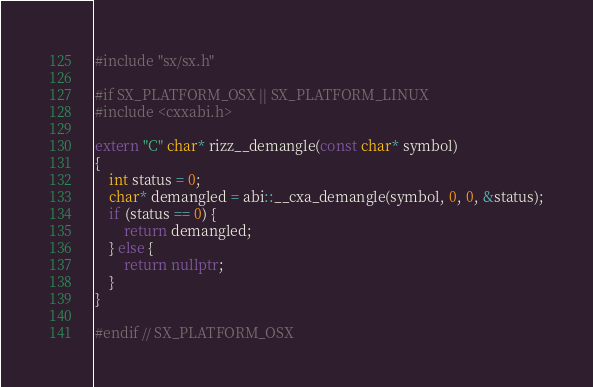<code> <loc_0><loc_0><loc_500><loc_500><_C++_>#include "sx/sx.h"

#if SX_PLATFORM_OSX || SX_PLATFORM_LINUX
#include <cxxabi.h>

extern "C" char* rizz__demangle(const char* symbol)
{
    int status = 0;
    char* demangled = abi::__cxa_demangle(symbol, 0, 0, &status);
    if (status == 0) {
        return demangled;
    } else {
        return nullptr;
    }
}

#endif // SX_PLATFORM_OSX
</code> 